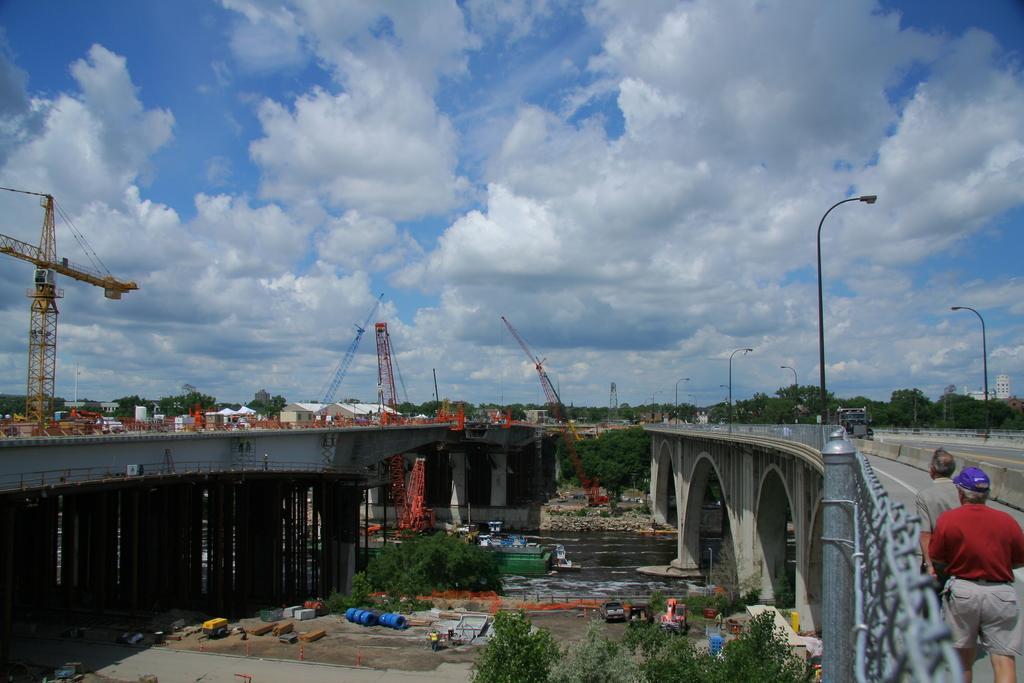Could you give a brief overview of what you see in this image? These are the bridges. I can see the tower cranes. On the right side of the image, there are two people standing. This is a vehicle on the bridge. I can see the street lights. These are the trees. At the bottom of the image, I can see the vehicles. These are the clouds in the sky. 